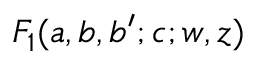<formula> <loc_0><loc_0><loc_500><loc_500>F _ { 1 } ( a , b , b ^ { \prime } ; c ; w , z )</formula> 